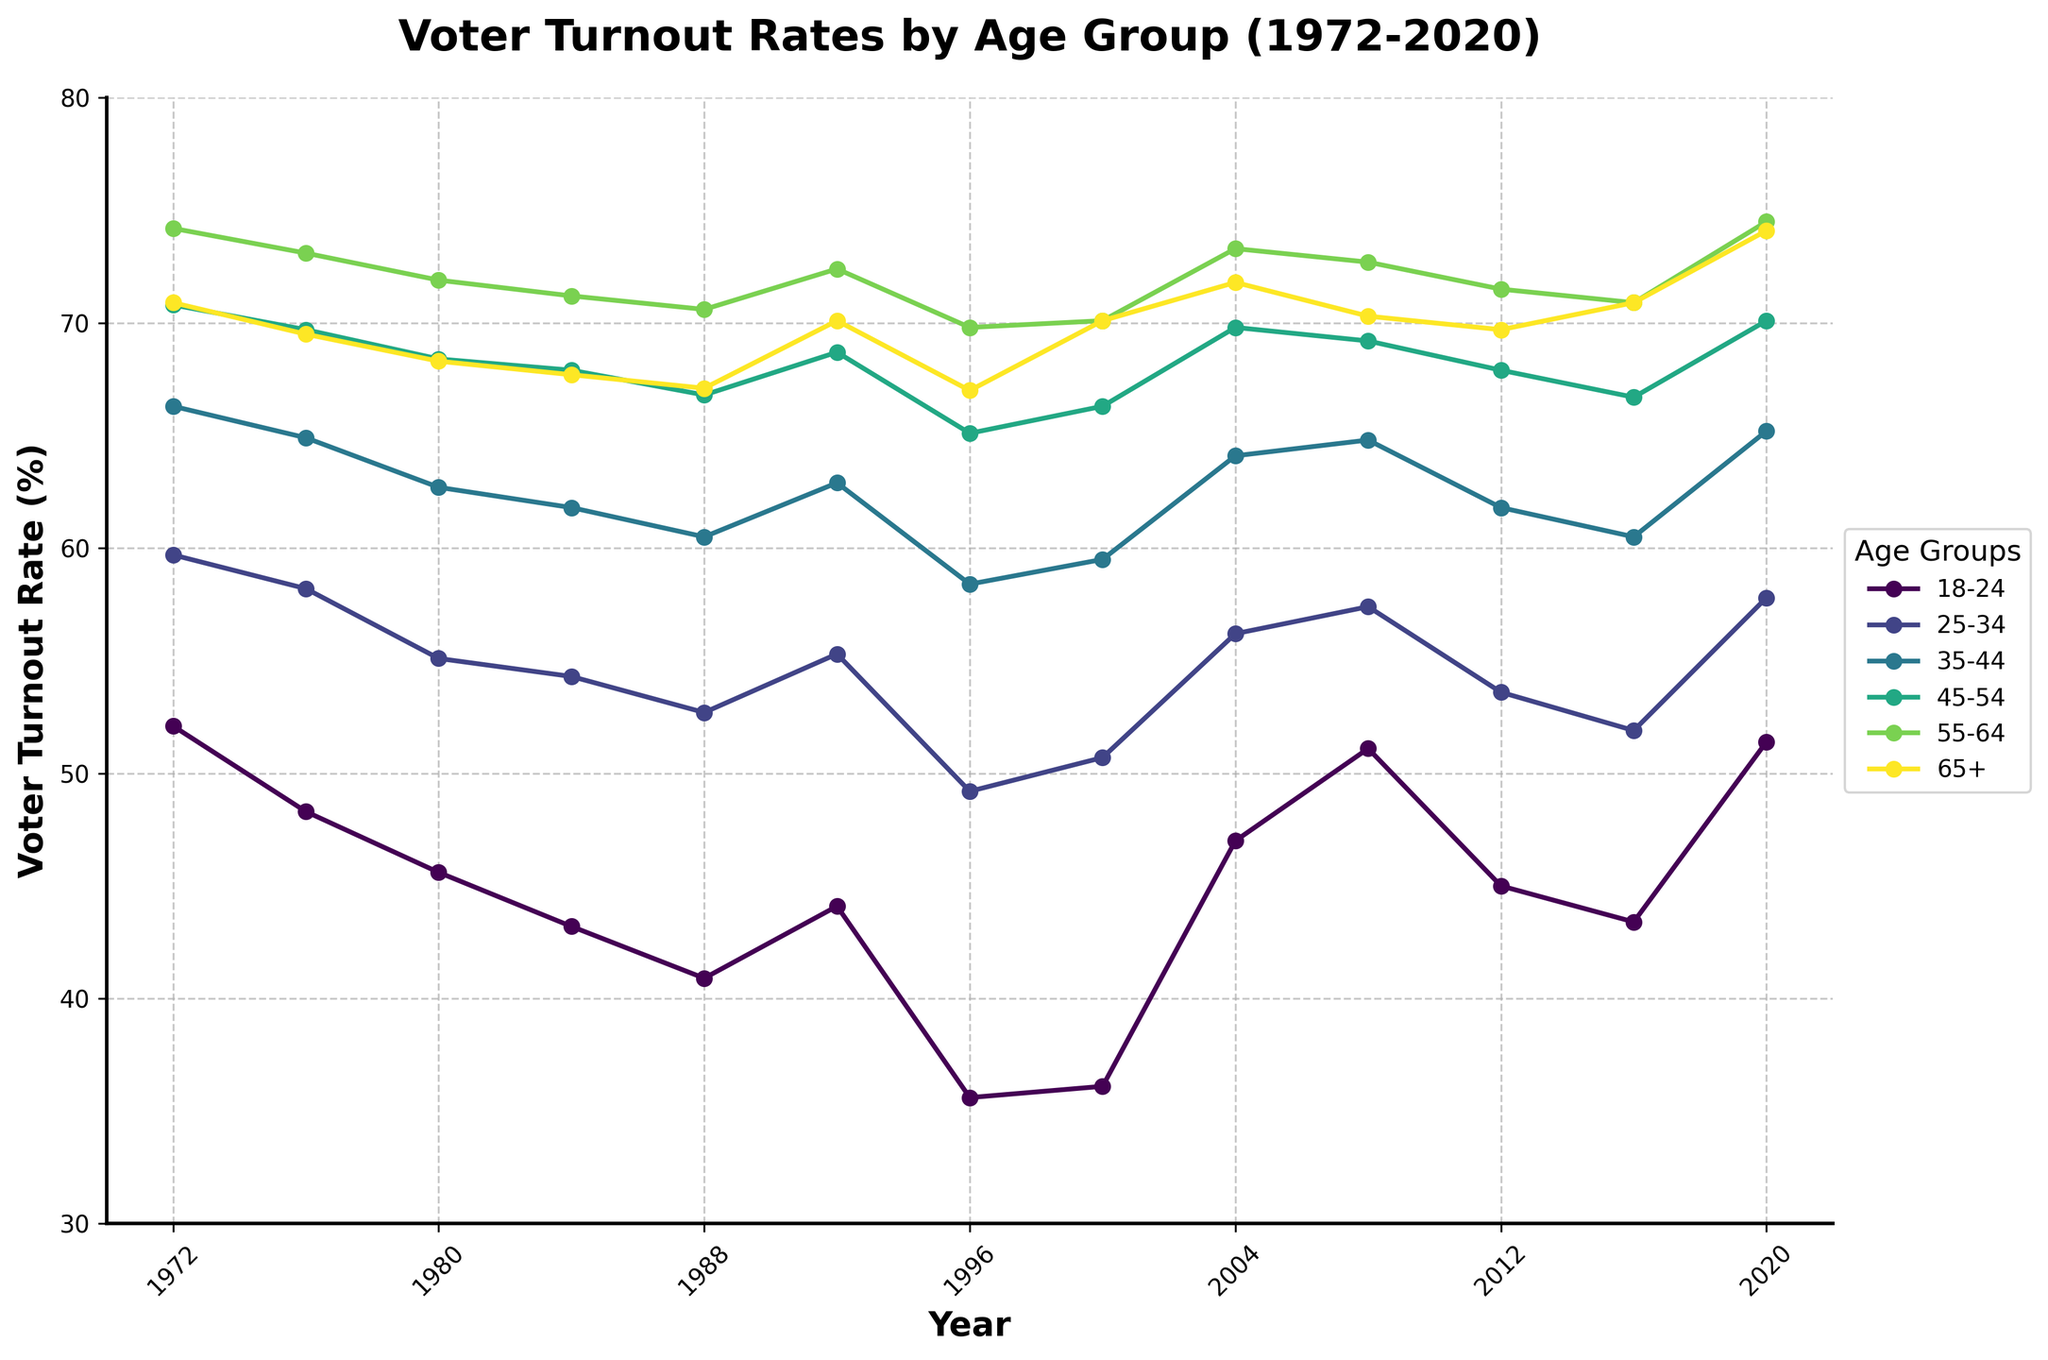Which age group had the highest voter turnout in 1972? By observing the plot for the year 1972, the data points for each age group should be checked to see which one is the highest. The group 55-64 had the highest turnout in 1972.
Answer: 55-64 How did the voter turnout for the 18-24 age group compare between 1996 and 2020? Comparing the data points for the years 1996 and 2020 for the 18-24 age group, the turnout rate increased from 35.6% in 1996 to 51.4% in 2020.
Answer: Increased Which year saw the highest voter turnout for the age group 65+? By observing the plot lines for each age group, the peak for the age group 65+ is in 2020.
Answer: 2020 What is the difference in voter turnout between the 25-34 and 45-54 age groups in 2008? For the year 2008, the turnout rates for the 25-34 and 45-54 age groups are 57.4% and 69.2%, respectively. The difference is 69.2% - 57.4% = 11.8%.
Answer: 11.8% Which age group exhibited the most significant increase in voter turnout from 1976 to 2020? Observing the start and end points for each group from 1976 to 2020, the 65+ group increased from 69.5% to 74.1%, giving an increase of 4.6%. The highest increase is for the 18-24 group, which increased from 48.3% to 51.4%, an increase of 3.1%.
Answer: 18-24 What trend can you observe in the voter turnout rates for the 45-54 age group over the entire period shown? Reviewing the data points connected as a line for the 45-54 age group from 1972 to 2020, the turnout shows minor oscillations but generally remains steady with small variations.
Answer: Steady Which age group showed the least fluctuation in voter turnout rates over the years? Comparing the spread of data points for each age group over the years, the age group 65+ shows the least fluctuation, with marginal changes throughout the period.
Answer: 65+ What was the average voter turnout rate for the 18-24 age group over the 50-year period? Add the turnout values for the 18-24 age group for all the given years and then divide by the number of years: (52.1 + 48.3 + 45.6 + 43.2 + 40.9 + 44.1 + 35.6 + 36.1 + 47.0 + 51.1 + 45.0 + 43.4 + 51.4) / 13. The sum is 584.8, so the average is 584.8 / 13 = approximately 45.0%.
Answer: 45.0% In which year did the 35-44 age group have the lowest voter turnout? Observing the lowest point for the turnout line of the 35-44 age group, the year with the least turnout is 1996, with a value of 58.4%.
Answer: 1996 